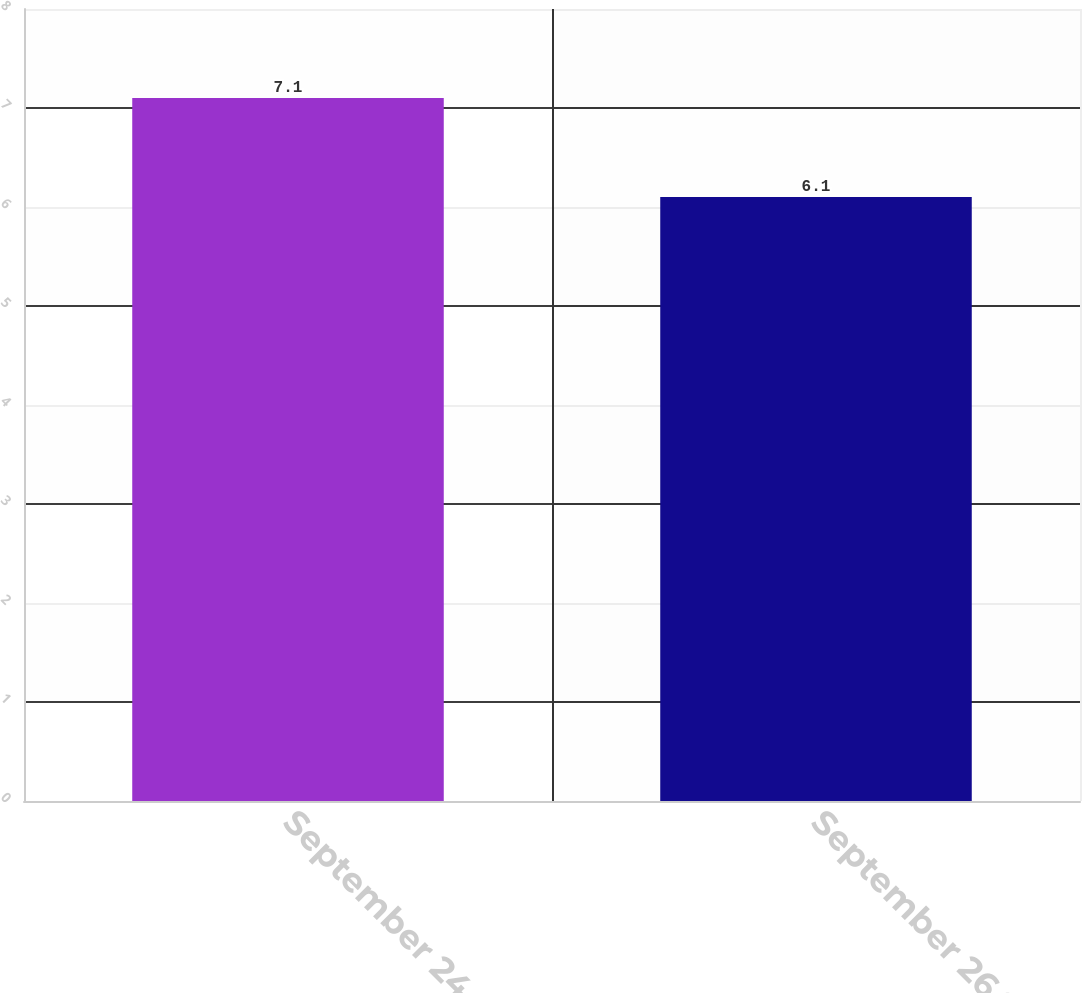Convert chart to OTSL. <chart><loc_0><loc_0><loc_500><loc_500><bar_chart><fcel>September 24 2016<fcel>September 26 2015<nl><fcel>7.1<fcel>6.1<nl></chart> 